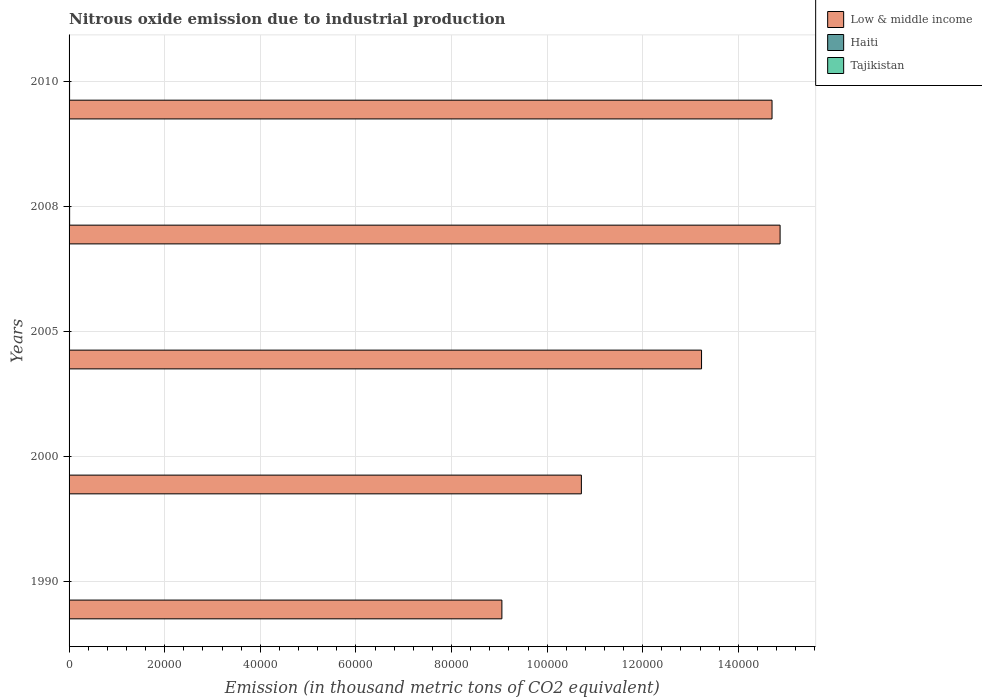How many bars are there on the 5th tick from the top?
Provide a succinct answer. 3. How many bars are there on the 5th tick from the bottom?
Give a very brief answer. 3. What is the amount of nitrous oxide emitted in Tajikistan in 1990?
Give a very brief answer. 31.2. Across all years, what is the maximum amount of nitrous oxide emitted in Haiti?
Offer a very short reply. 116. Across all years, what is the minimum amount of nitrous oxide emitted in Low & middle income?
Provide a short and direct response. 9.05e+04. In which year was the amount of nitrous oxide emitted in Low & middle income maximum?
Make the answer very short. 2008. In which year was the amount of nitrous oxide emitted in Low & middle income minimum?
Ensure brevity in your answer.  1990. What is the total amount of nitrous oxide emitted in Haiti in the graph?
Your answer should be very brief. 449.2. What is the difference between the amount of nitrous oxide emitted in Haiti in 1990 and that in 2010?
Offer a terse response. -49.2. What is the difference between the amount of nitrous oxide emitted in Low & middle income in 2005 and the amount of nitrous oxide emitted in Tajikistan in 2000?
Keep it short and to the point. 1.32e+05. What is the average amount of nitrous oxide emitted in Low & middle income per year?
Ensure brevity in your answer.  1.25e+05. In the year 2008, what is the difference between the amount of nitrous oxide emitted in Tajikistan and amount of nitrous oxide emitted in Low & middle income?
Keep it short and to the point. -1.49e+05. What is the ratio of the amount of nitrous oxide emitted in Tajikistan in 2000 to that in 2005?
Offer a very short reply. 0.72. What is the difference between the highest and the second highest amount of nitrous oxide emitted in Low & middle income?
Provide a short and direct response. 1688.4. What is the difference between the highest and the lowest amount of nitrous oxide emitted in Low & middle income?
Offer a very short reply. 5.82e+04. In how many years, is the amount of nitrous oxide emitted in Haiti greater than the average amount of nitrous oxide emitted in Haiti taken over all years?
Make the answer very short. 3. What does the 3rd bar from the top in 2008 represents?
Give a very brief answer. Low & middle income. What does the 2nd bar from the bottom in 2010 represents?
Keep it short and to the point. Haiti. What is the difference between two consecutive major ticks on the X-axis?
Offer a terse response. 2.00e+04. Are the values on the major ticks of X-axis written in scientific E-notation?
Keep it short and to the point. No. Does the graph contain grids?
Your response must be concise. Yes. Where does the legend appear in the graph?
Keep it short and to the point. Top right. What is the title of the graph?
Provide a short and direct response. Nitrous oxide emission due to industrial production. Does "Lebanon" appear as one of the legend labels in the graph?
Offer a terse response. No. What is the label or title of the X-axis?
Provide a succinct answer. Emission (in thousand metric tons of CO2 equivalent). What is the label or title of the Y-axis?
Your answer should be compact. Years. What is the Emission (in thousand metric tons of CO2 equivalent) of Low & middle income in 1990?
Your answer should be very brief. 9.05e+04. What is the Emission (in thousand metric tons of CO2 equivalent) in Haiti in 1990?
Give a very brief answer. 56.6. What is the Emission (in thousand metric tons of CO2 equivalent) of Tajikistan in 1990?
Make the answer very short. 31.2. What is the Emission (in thousand metric tons of CO2 equivalent) in Low & middle income in 2000?
Give a very brief answer. 1.07e+05. What is the Emission (in thousand metric tons of CO2 equivalent) in Haiti in 2000?
Ensure brevity in your answer.  73.8. What is the Emission (in thousand metric tons of CO2 equivalent) of Low & middle income in 2005?
Your answer should be compact. 1.32e+05. What is the Emission (in thousand metric tons of CO2 equivalent) in Haiti in 2005?
Your answer should be compact. 97. What is the Emission (in thousand metric tons of CO2 equivalent) of Tajikistan in 2005?
Your answer should be very brief. 15.2. What is the Emission (in thousand metric tons of CO2 equivalent) in Low & middle income in 2008?
Provide a short and direct response. 1.49e+05. What is the Emission (in thousand metric tons of CO2 equivalent) in Haiti in 2008?
Provide a short and direct response. 116. What is the Emission (in thousand metric tons of CO2 equivalent) in Tajikistan in 2008?
Make the answer very short. 20.3. What is the Emission (in thousand metric tons of CO2 equivalent) in Low & middle income in 2010?
Give a very brief answer. 1.47e+05. What is the Emission (in thousand metric tons of CO2 equivalent) of Haiti in 2010?
Your answer should be very brief. 105.8. What is the Emission (in thousand metric tons of CO2 equivalent) of Tajikistan in 2010?
Offer a very short reply. 21.2. Across all years, what is the maximum Emission (in thousand metric tons of CO2 equivalent) in Low & middle income?
Make the answer very short. 1.49e+05. Across all years, what is the maximum Emission (in thousand metric tons of CO2 equivalent) of Haiti?
Provide a succinct answer. 116. Across all years, what is the maximum Emission (in thousand metric tons of CO2 equivalent) in Tajikistan?
Make the answer very short. 31.2. Across all years, what is the minimum Emission (in thousand metric tons of CO2 equivalent) in Low & middle income?
Your response must be concise. 9.05e+04. Across all years, what is the minimum Emission (in thousand metric tons of CO2 equivalent) of Haiti?
Your answer should be compact. 56.6. Across all years, what is the minimum Emission (in thousand metric tons of CO2 equivalent) of Tajikistan?
Make the answer very short. 10.9. What is the total Emission (in thousand metric tons of CO2 equivalent) of Low & middle income in the graph?
Offer a terse response. 6.26e+05. What is the total Emission (in thousand metric tons of CO2 equivalent) in Haiti in the graph?
Your answer should be compact. 449.2. What is the total Emission (in thousand metric tons of CO2 equivalent) of Tajikistan in the graph?
Your answer should be very brief. 98.8. What is the difference between the Emission (in thousand metric tons of CO2 equivalent) of Low & middle income in 1990 and that in 2000?
Offer a terse response. -1.66e+04. What is the difference between the Emission (in thousand metric tons of CO2 equivalent) of Haiti in 1990 and that in 2000?
Your answer should be compact. -17.2. What is the difference between the Emission (in thousand metric tons of CO2 equivalent) of Tajikistan in 1990 and that in 2000?
Ensure brevity in your answer.  20.3. What is the difference between the Emission (in thousand metric tons of CO2 equivalent) in Low & middle income in 1990 and that in 2005?
Offer a terse response. -4.18e+04. What is the difference between the Emission (in thousand metric tons of CO2 equivalent) in Haiti in 1990 and that in 2005?
Give a very brief answer. -40.4. What is the difference between the Emission (in thousand metric tons of CO2 equivalent) in Tajikistan in 1990 and that in 2005?
Provide a short and direct response. 16. What is the difference between the Emission (in thousand metric tons of CO2 equivalent) of Low & middle income in 1990 and that in 2008?
Make the answer very short. -5.82e+04. What is the difference between the Emission (in thousand metric tons of CO2 equivalent) in Haiti in 1990 and that in 2008?
Your response must be concise. -59.4. What is the difference between the Emission (in thousand metric tons of CO2 equivalent) in Low & middle income in 1990 and that in 2010?
Ensure brevity in your answer.  -5.65e+04. What is the difference between the Emission (in thousand metric tons of CO2 equivalent) in Haiti in 1990 and that in 2010?
Offer a very short reply. -49.2. What is the difference between the Emission (in thousand metric tons of CO2 equivalent) of Low & middle income in 2000 and that in 2005?
Offer a terse response. -2.51e+04. What is the difference between the Emission (in thousand metric tons of CO2 equivalent) in Haiti in 2000 and that in 2005?
Give a very brief answer. -23.2. What is the difference between the Emission (in thousand metric tons of CO2 equivalent) of Low & middle income in 2000 and that in 2008?
Offer a very short reply. -4.16e+04. What is the difference between the Emission (in thousand metric tons of CO2 equivalent) in Haiti in 2000 and that in 2008?
Provide a short and direct response. -42.2. What is the difference between the Emission (in thousand metric tons of CO2 equivalent) in Tajikistan in 2000 and that in 2008?
Keep it short and to the point. -9.4. What is the difference between the Emission (in thousand metric tons of CO2 equivalent) in Low & middle income in 2000 and that in 2010?
Your answer should be compact. -3.99e+04. What is the difference between the Emission (in thousand metric tons of CO2 equivalent) in Haiti in 2000 and that in 2010?
Give a very brief answer. -32. What is the difference between the Emission (in thousand metric tons of CO2 equivalent) in Tajikistan in 2000 and that in 2010?
Your response must be concise. -10.3. What is the difference between the Emission (in thousand metric tons of CO2 equivalent) of Low & middle income in 2005 and that in 2008?
Ensure brevity in your answer.  -1.64e+04. What is the difference between the Emission (in thousand metric tons of CO2 equivalent) of Haiti in 2005 and that in 2008?
Your answer should be compact. -19. What is the difference between the Emission (in thousand metric tons of CO2 equivalent) of Tajikistan in 2005 and that in 2008?
Your answer should be compact. -5.1. What is the difference between the Emission (in thousand metric tons of CO2 equivalent) of Low & middle income in 2005 and that in 2010?
Your answer should be very brief. -1.47e+04. What is the difference between the Emission (in thousand metric tons of CO2 equivalent) in Low & middle income in 2008 and that in 2010?
Provide a short and direct response. 1688.4. What is the difference between the Emission (in thousand metric tons of CO2 equivalent) of Haiti in 2008 and that in 2010?
Ensure brevity in your answer.  10.2. What is the difference between the Emission (in thousand metric tons of CO2 equivalent) of Low & middle income in 1990 and the Emission (in thousand metric tons of CO2 equivalent) of Haiti in 2000?
Ensure brevity in your answer.  9.05e+04. What is the difference between the Emission (in thousand metric tons of CO2 equivalent) of Low & middle income in 1990 and the Emission (in thousand metric tons of CO2 equivalent) of Tajikistan in 2000?
Provide a short and direct response. 9.05e+04. What is the difference between the Emission (in thousand metric tons of CO2 equivalent) of Haiti in 1990 and the Emission (in thousand metric tons of CO2 equivalent) of Tajikistan in 2000?
Provide a short and direct response. 45.7. What is the difference between the Emission (in thousand metric tons of CO2 equivalent) in Low & middle income in 1990 and the Emission (in thousand metric tons of CO2 equivalent) in Haiti in 2005?
Offer a very short reply. 9.04e+04. What is the difference between the Emission (in thousand metric tons of CO2 equivalent) of Low & middle income in 1990 and the Emission (in thousand metric tons of CO2 equivalent) of Tajikistan in 2005?
Ensure brevity in your answer.  9.05e+04. What is the difference between the Emission (in thousand metric tons of CO2 equivalent) in Haiti in 1990 and the Emission (in thousand metric tons of CO2 equivalent) in Tajikistan in 2005?
Your answer should be very brief. 41.4. What is the difference between the Emission (in thousand metric tons of CO2 equivalent) in Low & middle income in 1990 and the Emission (in thousand metric tons of CO2 equivalent) in Haiti in 2008?
Your answer should be compact. 9.04e+04. What is the difference between the Emission (in thousand metric tons of CO2 equivalent) of Low & middle income in 1990 and the Emission (in thousand metric tons of CO2 equivalent) of Tajikistan in 2008?
Your answer should be compact. 9.05e+04. What is the difference between the Emission (in thousand metric tons of CO2 equivalent) of Haiti in 1990 and the Emission (in thousand metric tons of CO2 equivalent) of Tajikistan in 2008?
Your answer should be compact. 36.3. What is the difference between the Emission (in thousand metric tons of CO2 equivalent) of Low & middle income in 1990 and the Emission (in thousand metric tons of CO2 equivalent) of Haiti in 2010?
Ensure brevity in your answer.  9.04e+04. What is the difference between the Emission (in thousand metric tons of CO2 equivalent) of Low & middle income in 1990 and the Emission (in thousand metric tons of CO2 equivalent) of Tajikistan in 2010?
Your answer should be compact. 9.05e+04. What is the difference between the Emission (in thousand metric tons of CO2 equivalent) of Haiti in 1990 and the Emission (in thousand metric tons of CO2 equivalent) of Tajikistan in 2010?
Ensure brevity in your answer.  35.4. What is the difference between the Emission (in thousand metric tons of CO2 equivalent) of Low & middle income in 2000 and the Emission (in thousand metric tons of CO2 equivalent) of Haiti in 2005?
Provide a succinct answer. 1.07e+05. What is the difference between the Emission (in thousand metric tons of CO2 equivalent) of Low & middle income in 2000 and the Emission (in thousand metric tons of CO2 equivalent) of Tajikistan in 2005?
Ensure brevity in your answer.  1.07e+05. What is the difference between the Emission (in thousand metric tons of CO2 equivalent) in Haiti in 2000 and the Emission (in thousand metric tons of CO2 equivalent) in Tajikistan in 2005?
Provide a short and direct response. 58.6. What is the difference between the Emission (in thousand metric tons of CO2 equivalent) in Low & middle income in 2000 and the Emission (in thousand metric tons of CO2 equivalent) in Haiti in 2008?
Your answer should be compact. 1.07e+05. What is the difference between the Emission (in thousand metric tons of CO2 equivalent) in Low & middle income in 2000 and the Emission (in thousand metric tons of CO2 equivalent) in Tajikistan in 2008?
Your answer should be very brief. 1.07e+05. What is the difference between the Emission (in thousand metric tons of CO2 equivalent) in Haiti in 2000 and the Emission (in thousand metric tons of CO2 equivalent) in Tajikistan in 2008?
Your response must be concise. 53.5. What is the difference between the Emission (in thousand metric tons of CO2 equivalent) of Low & middle income in 2000 and the Emission (in thousand metric tons of CO2 equivalent) of Haiti in 2010?
Make the answer very short. 1.07e+05. What is the difference between the Emission (in thousand metric tons of CO2 equivalent) in Low & middle income in 2000 and the Emission (in thousand metric tons of CO2 equivalent) in Tajikistan in 2010?
Your answer should be very brief. 1.07e+05. What is the difference between the Emission (in thousand metric tons of CO2 equivalent) in Haiti in 2000 and the Emission (in thousand metric tons of CO2 equivalent) in Tajikistan in 2010?
Keep it short and to the point. 52.6. What is the difference between the Emission (in thousand metric tons of CO2 equivalent) of Low & middle income in 2005 and the Emission (in thousand metric tons of CO2 equivalent) of Haiti in 2008?
Make the answer very short. 1.32e+05. What is the difference between the Emission (in thousand metric tons of CO2 equivalent) in Low & middle income in 2005 and the Emission (in thousand metric tons of CO2 equivalent) in Tajikistan in 2008?
Keep it short and to the point. 1.32e+05. What is the difference between the Emission (in thousand metric tons of CO2 equivalent) in Haiti in 2005 and the Emission (in thousand metric tons of CO2 equivalent) in Tajikistan in 2008?
Ensure brevity in your answer.  76.7. What is the difference between the Emission (in thousand metric tons of CO2 equivalent) in Low & middle income in 2005 and the Emission (in thousand metric tons of CO2 equivalent) in Haiti in 2010?
Keep it short and to the point. 1.32e+05. What is the difference between the Emission (in thousand metric tons of CO2 equivalent) in Low & middle income in 2005 and the Emission (in thousand metric tons of CO2 equivalent) in Tajikistan in 2010?
Provide a succinct answer. 1.32e+05. What is the difference between the Emission (in thousand metric tons of CO2 equivalent) in Haiti in 2005 and the Emission (in thousand metric tons of CO2 equivalent) in Tajikistan in 2010?
Offer a very short reply. 75.8. What is the difference between the Emission (in thousand metric tons of CO2 equivalent) in Low & middle income in 2008 and the Emission (in thousand metric tons of CO2 equivalent) in Haiti in 2010?
Keep it short and to the point. 1.49e+05. What is the difference between the Emission (in thousand metric tons of CO2 equivalent) in Low & middle income in 2008 and the Emission (in thousand metric tons of CO2 equivalent) in Tajikistan in 2010?
Give a very brief answer. 1.49e+05. What is the difference between the Emission (in thousand metric tons of CO2 equivalent) in Haiti in 2008 and the Emission (in thousand metric tons of CO2 equivalent) in Tajikistan in 2010?
Provide a short and direct response. 94.8. What is the average Emission (in thousand metric tons of CO2 equivalent) of Low & middle income per year?
Make the answer very short. 1.25e+05. What is the average Emission (in thousand metric tons of CO2 equivalent) in Haiti per year?
Give a very brief answer. 89.84. What is the average Emission (in thousand metric tons of CO2 equivalent) in Tajikistan per year?
Ensure brevity in your answer.  19.76. In the year 1990, what is the difference between the Emission (in thousand metric tons of CO2 equivalent) of Low & middle income and Emission (in thousand metric tons of CO2 equivalent) of Haiti?
Give a very brief answer. 9.05e+04. In the year 1990, what is the difference between the Emission (in thousand metric tons of CO2 equivalent) in Low & middle income and Emission (in thousand metric tons of CO2 equivalent) in Tajikistan?
Give a very brief answer. 9.05e+04. In the year 1990, what is the difference between the Emission (in thousand metric tons of CO2 equivalent) in Haiti and Emission (in thousand metric tons of CO2 equivalent) in Tajikistan?
Offer a very short reply. 25.4. In the year 2000, what is the difference between the Emission (in thousand metric tons of CO2 equivalent) in Low & middle income and Emission (in thousand metric tons of CO2 equivalent) in Haiti?
Your answer should be compact. 1.07e+05. In the year 2000, what is the difference between the Emission (in thousand metric tons of CO2 equivalent) of Low & middle income and Emission (in thousand metric tons of CO2 equivalent) of Tajikistan?
Ensure brevity in your answer.  1.07e+05. In the year 2000, what is the difference between the Emission (in thousand metric tons of CO2 equivalent) in Haiti and Emission (in thousand metric tons of CO2 equivalent) in Tajikistan?
Your answer should be very brief. 62.9. In the year 2005, what is the difference between the Emission (in thousand metric tons of CO2 equivalent) of Low & middle income and Emission (in thousand metric tons of CO2 equivalent) of Haiti?
Provide a short and direct response. 1.32e+05. In the year 2005, what is the difference between the Emission (in thousand metric tons of CO2 equivalent) of Low & middle income and Emission (in thousand metric tons of CO2 equivalent) of Tajikistan?
Provide a succinct answer. 1.32e+05. In the year 2005, what is the difference between the Emission (in thousand metric tons of CO2 equivalent) of Haiti and Emission (in thousand metric tons of CO2 equivalent) of Tajikistan?
Provide a succinct answer. 81.8. In the year 2008, what is the difference between the Emission (in thousand metric tons of CO2 equivalent) of Low & middle income and Emission (in thousand metric tons of CO2 equivalent) of Haiti?
Your answer should be compact. 1.49e+05. In the year 2008, what is the difference between the Emission (in thousand metric tons of CO2 equivalent) in Low & middle income and Emission (in thousand metric tons of CO2 equivalent) in Tajikistan?
Make the answer very short. 1.49e+05. In the year 2008, what is the difference between the Emission (in thousand metric tons of CO2 equivalent) of Haiti and Emission (in thousand metric tons of CO2 equivalent) of Tajikistan?
Make the answer very short. 95.7. In the year 2010, what is the difference between the Emission (in thousand metric tons of CO2 equivalent) in Low & middle income and Emission (in thousand metric tons of CO2 equivalent) in Haiti?
Keep it short and to the point. 1.47e+05. In the year 2010, what is the difference between the Emission (in thousand metric tons of CO2 equivalent) in Low & middle income and Emission (in thousand metric tons of CO2 equivalent) in Tajikistan?
Offer a very short reply. 1.47e+05. In the year 2010, what is the difference between the Emission (in thousand metric tons of CO2 equivalent) of Haiti and Emission (in thousand metric tons of CO2 equivalent) of Tajikistan?
Offer a very short reply. 84.6. What is the ratio of the Emission (in thousand metric tons of CO2 equivalent) in Low & middle income in 1990 to that in 2000?
Provide a succinct answer. 0.84. What is the ratio of the Emission (in thousand metric tons of CO2 equivalent) in Haiti in 1990 to that in 2000?
Make the answer very short. 0.77. What is the ratio of the Emission (in thousand metric tons of CO2 equivalent) of Tajikistan in 1990 to that in 2000?
Keep it short and to the point. 2.86. What is the ratio of the Emission (in thousand metric tons of CO2 equivalent) in Low & middle income in 1990 to that in 2005?
Give a very brief answer. 0.68. What is the ratio of the Emission (in thousand metric tons of CO2 equivalent) of Haiti in 1990 to that in 2005?
Offer a very short reply. 0.58. What is the ratio of the Emission (in thousand metric tons of CO2 equivalent) of Tajikistan in 1990 to that in 2005?
Keep it short and to the point. 2.05. What is the ratio of the Emission (in thousand metric tons of CO2 equivalent) of Low & middle income in 1990 to that in 2008?
Your answer should be compact. 0.61. What is the ratio of the Emission (in thousand metric tons of CO2 equivalent) of Haiti in 1990 to that in 2008?
Your answer should be very brief. 0.49. What is the ratio of the Emission (in thousand metric tons of CO2 equivalent) in Tajikistan in 1990 to that in 2008?
Your answer should be very brief. 1.54. What is the ratio of the Emission (in thousand metric tons of CO2 equivalent) of Low & middle income in 1990 to that in 2010?
Offer a very short reply. 0.62. What is the ratio of the Emission (in thousand metric tons of CO2 equivalent) of Haiti in 1990 to that in 2010?
Ensure brevity in your answer.  0.54. What is the ratio of the Emission (in thousand metric tons of CO2 equivalent) of Tajikistan in 1990 to that in 2010?
Offer a terse response. 1.47. What is the ratio of the Emission (in thousand metric tons of CO2 equivalent) in Low & middle income in 2000 to that in 2005?
Make the answer very short. 0.81. What is the ratio of the Emission (in thousand metric tons of CO2 equivalent) in Haiti in 2000 to that in 2005?
Your answer should be compact. 0.76. What is the ratio of the Emission (in thousand metric tons of CO2 equivalent) of Tajikistan in 2000 to that in 2005?
Provide a short and direct response. 0.72. What is the ratio of the Emission (in thousand metric tons of CO2 equivalent) in Low & middle income in 2000 to that in 2008?
Your answer should be very brief. 0.72. What is the ratio of the Emission (in thousand metric tons of CO2 equivalent) of Haiti in 2000 to that in 2008?
Your answer should be very brief. 0.64. What is the ratio of the Emission (in thousand metric tons of CO2 equivalent) in Tajikistan in 2000 to that in 2008?
Ensure brevity in your answer.  0.54. What is the ratio of the Emission (in thousand metric tons of CO2 equivalent) in Low & middle income in 2000 to that in 2010?
Provide a succinct answer. 0.73. What is the ratio of the Emission (in thousand metric tons of CO2 equivalent) of Haiti in 2000 to that in 2010?
Your answer should be compact. 0.7. What is the ratio of the Emission (in thousand metric tons of CO2 equivalent) in Tajikistan in 2000 to that in 2010?
Your answer should be compact. 0.51. What is the ratio of the Emission (in thousand metric tons of CO2 equivalent) in Low & middle income in 2005 to that in 2008?
Your answer should be very brief. 0.89. What is the ratio of the Emission (in thousand metric tons of CO2 equivalent) in Haiti in 2005 to that in 2008?
Offer a very short reply. 0.84. What is the ratio of the Emission (in thousand metric tons of CO2 equivalent) of Tajikistan in 2005 to that in 2008?
Provide a short and direct response. 0.75. What is the ratio of the Emission (in thousand metric tons of CO2 equivalent) in Low & middle income in 2005 to that in 2010?
Provide a short and direct response. 0.9. What is the ratio of the Emission (in thousand metric tons of CO2 equivalent) in Haiti in 2005 to that in 2010?
Make the answer very short. 0.92. What is the ratio of the Emission (in thousand metric tons of CO2 equivalent) of Tajikistan in 2005 to that in 2010?
Make the answer very short. 0.72. What is the ratio of the Emission (in thousand metric tons of CO2 equivalent) in Low & middle income in 2008 to that in 2010?
Make the answer very short. 1.01. What is the ratio of the Emission (in thousand metric tons of CO2 equivalent) of Haiti in 2008 to that in 2010?
Make the answer very short. 1.1. What is the ratio of the Emission (in thousand metric tons of CO2 equivalent) of Tajikistan in 2008 to that in 2010?
Offer a very short reply. 0.96. What is the difference between the highest and the second highest Emission (in thousand metric tons of CO2 equivalent) in Low & middle income?
Keep it short and to the point. 1688.4. What is the difference between the highest and the second highest Emission (in thousand metric tons of CO2 equivalent) of Haiti?
Provide a short and direct response. 10.2. What is the difference between the highest and the second highest Emission (in thousand metric tons of CO2 equivalent) in Tajikistan?
Offer a terse response. 10. What is the difference between the highest and the lowest Emission (in thousand metric tons of CO2 equivalent) in Low & middle income?
Give a very brief answer. 5.82e+04. What is the difference between the highest and the lowest Emission (in thousand metric tons of CO2 equivalent) in Haiti?
Your response must be concise. 59.4. What is the difference between the highest and the lowest Emission (in thousand metric tons of CO2 equivalent) in Tajikistan?
Keep it short and to the point. 20.3. 